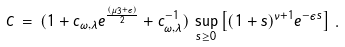<formula> <loc_0><loc_0><loc_500><loc_500>C \, = \, ( 1 + c _ { \omega , \lambda } e ^ { \frac { ( \mu _ { 3 } + \epsilon ) } { 2 } } + c _ { \omega , \lambda } ^ { - 1 } ) \, \sup _ { s \geq 0 } \left [ ( 1 + s ) ^ { \nu + 1 } e ^ { - \epsilon s } \right ] \, .</formula> 